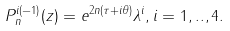<formula> <loc_0><loc_0><loc_500><loc_500>P ^ { i ( - 1 ) } _ { n } ( z ) = e ^ { 2 n ( \tau + i \theta ) } \lambda ^ { i } , i = 1 , . . , 4 .</formula> 